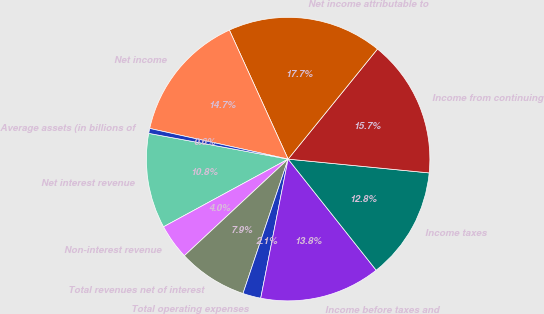Convert chart. <chart><loc_0><loc_0><loc_500><loc_500><pie_chart><fcel>Net interest revenue<fcel>Non-interest revenue<fcel>Total revenues net of interest<fcel>Total operating expenses<fcel>Income before taxes and<fcel>Income taxes<fcel>Income from continuing<fcel>Net income attributable to<fcel>Net income<fcel>Average assets (in billions of<nl><fcel>10.83%<fcel>4.01%<fcel>7.91%<fcel>2.06%<fcel>13.76%<fcel>12.78%<fcel>15.7%<fcel>17.65%<fcel>14.73%<fcel>0.56%<nl></chart> 